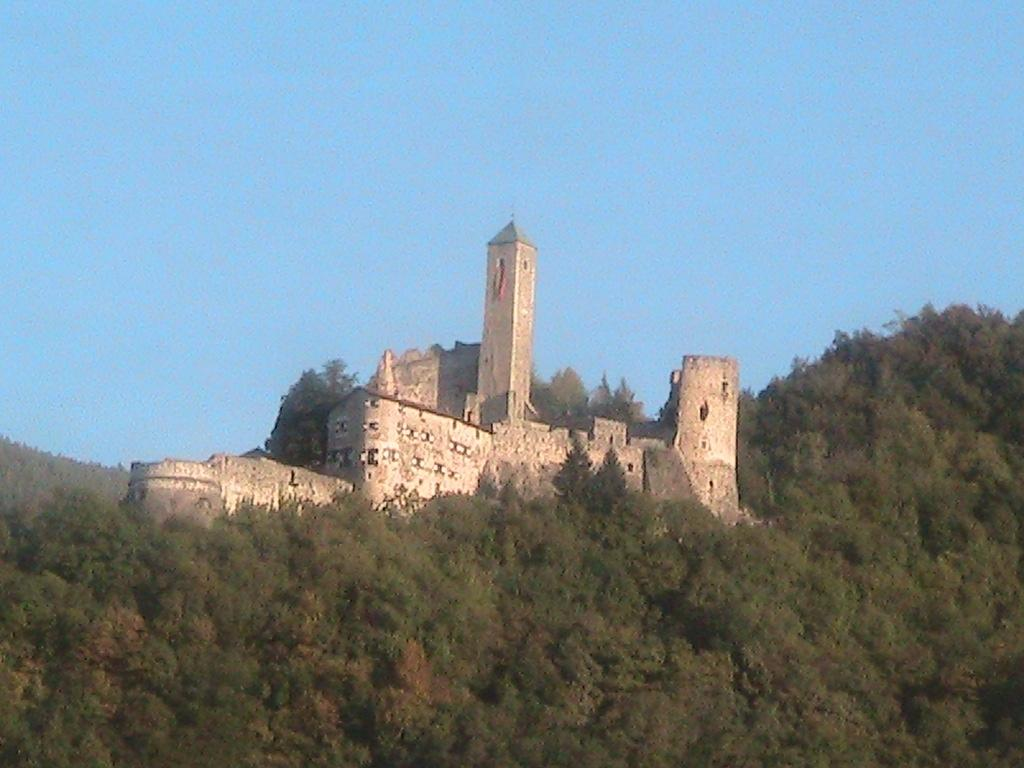What type of structure is visible in the image? There is a fort in the image. What type of vegetation can be seen in the image? There are trees in the image. What is visible in the background of the image? The sky is visible in the background of the image. What type of sail can be seen on the fort in the image? There is no sail present on the fort in the image. How does the temper of the trees affect the appearance of the fort in the image? The temper of the trees does not affect the appearance of the fort in the image, as trees do not have a temper. 